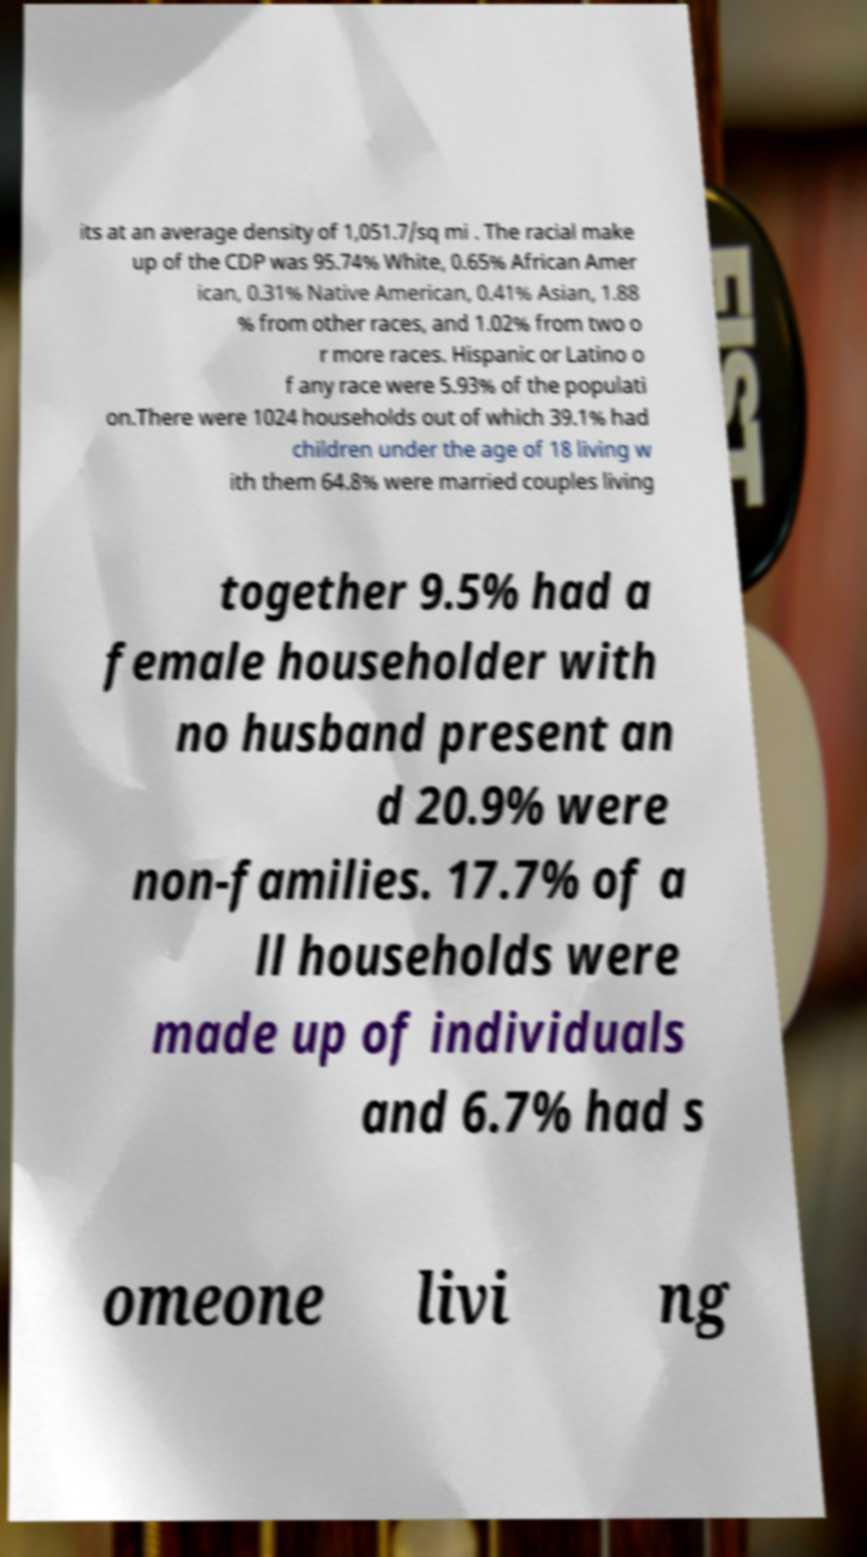Please identify and transcribe the text found in this image. its at an average density of 1,051.7/sq mi . The racial make up of the CDP was 95.74% White, 0.65% African Amer ican, 0.31% Native American, 0.41% Asian, 1.88 % from other races, and 1.02% from two o r more races. Hispanic or Latino o f any race were 5.93% of the populati on.There were 1024 households out of which 39.1% had children under the age of 18 living w ith them 64.8% were married couples living together 9.5% had a female householder with no husband present an d 20.9% were non-families. 17.7% of a ll households were made up of individuals and 6.7% had s omeone livi ng 